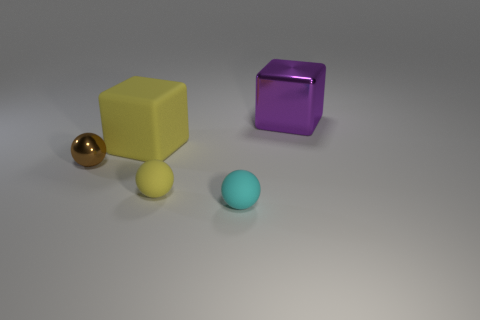How many objects are either brown shiny balls or objects that are behind the small metal sphere?
Ensure brevity in your answer.  3. There is a metallic ball; is it the same size as the rubber thing that is behind the tiny brown thing?
Offer a terse response. No. How many blocks are large shiny objects or big things?
Give a very brief answer. 2. What number of objects are both in front of the purple block and behind the small cyan matte thing?
Ensure brevity in your answer.  3. How many other things are there of the same color as the large shiny block?
Make the answer very short. 0. What shape is the yellow matte object that is behind the metallic ball?
Your answer should be compact. Cube. Are the big yellow object and the tiny yellow thing made of the same material?
Your response must be concise. Yes. Is there any other thing that has the same size as the purple thing?
Your answer should be compact. Yes. What number of objects are on the left side of the large metal object?
Provide a succinct answer. 4. What is the shape of the rubber thing behind the matte sphere that is behind the small cyan sphere?
Provide a short and direct response. Cube. 